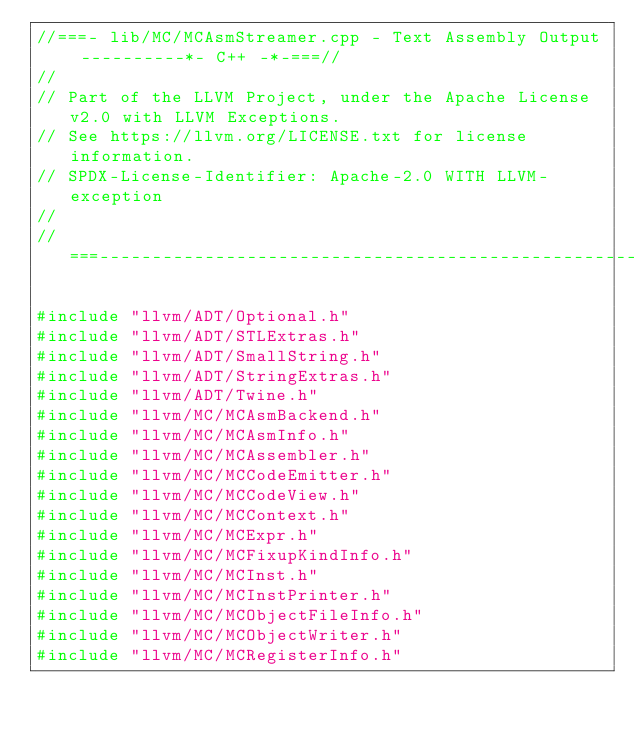<code> <loc_0><loc_0><loc_500><loc_500><_C++_>//===- lib/MC/MCAsmStreamer.cpp - Text Assembly Output ----------*- C++ -*-===//
//
// Part of the LLVM Project, under the Apache License v2.0 with LLVM Exceptions.
// See https://llvm.org/LICENSE.txt for license information.
// SPDX-License-Identifier: Apache-2.0 WITH LLVM-exception
//
//===----------------------------------------------------------------------===//

#include "llvm/ADT/Optional.h"
#include "llvm/ADT/STLExtras.h"
#include "llvm/ADT/SmallString.h"
#include "llvm/ADT/StringExtras.h"
#include "llvm/ADT/Twine.h"
#include "llvm/MC/MCAsmBackend.h"
#include "llvm/MC/MCAsmInfo.h"
#include "llvm/MC/MCAssembler.h"
#include "llvm/MC/MCCodeEmitter.h"
#include "llvm/MC/MCCodeView.h"
#include "llvm/MC/MCContext.h"
#include "llvm/MC/MCExpr.h"
#include "llvm/MC/MCFixupKindInfo.h"
#include "llvm/MC/MCInst.h"
#include "llvm/MC/MCInstPrinter.h"
#include "llvm/MC/MCObjectFileInfo.h"
#include "llvm/MC/MCObjectWriter.h"
#include "llvm/MC/MCRegisterInfo.h"</code> 